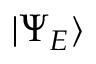Convert formula to latex. <formula><loc_0><loc_0><loc_500><loc_500>| \Psi _ { E } \rangle</formula> 